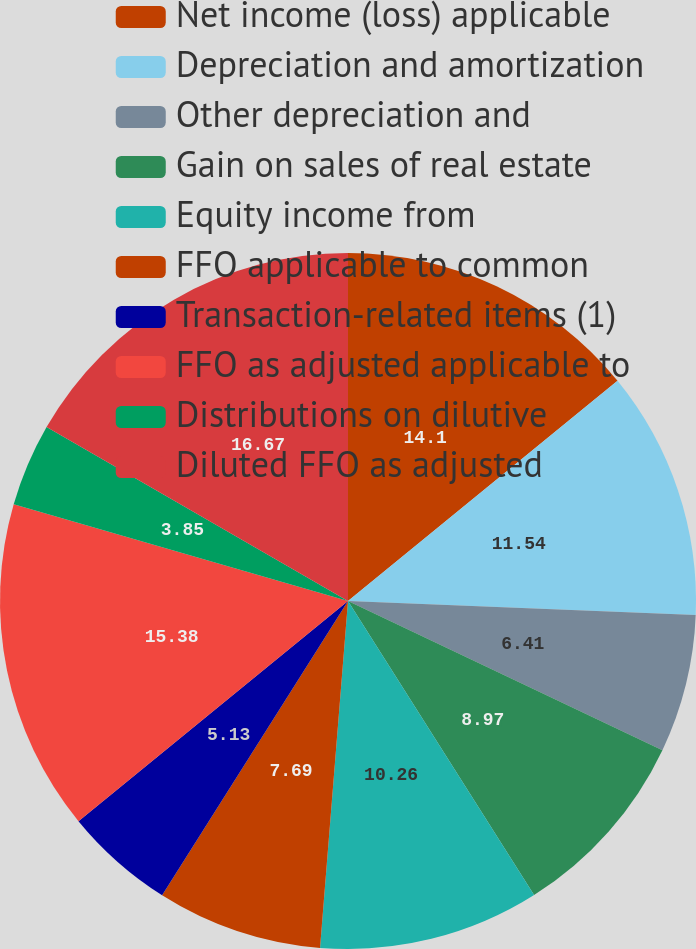Convert chart to OTSL. <chart><loc_0><loc_0><loc_500><loc_500><pie_chart><fcel>Net income (loss) applicable<fcel>Depreciation and amortization<fcel>Other depreciation and<fcel>Gain on sales of real estate<fcel>Equity income from<fcel>FFO applicable to common<fcel>Transaction-related items (1)<fcel>FFO as adjusted applicable to<fcel>Distributions on dilutive<fcel>Diluted FFO as adjusted<nl><fcel>14.1%<fcel>11.54%<fcel>6.41%<fcel>8.97%<fcel>10.26%<fcel>7.69%<fcel>5.13%<fcel>15.38%<fcel>3.85%<fcel>16.67%<nl></chart> 